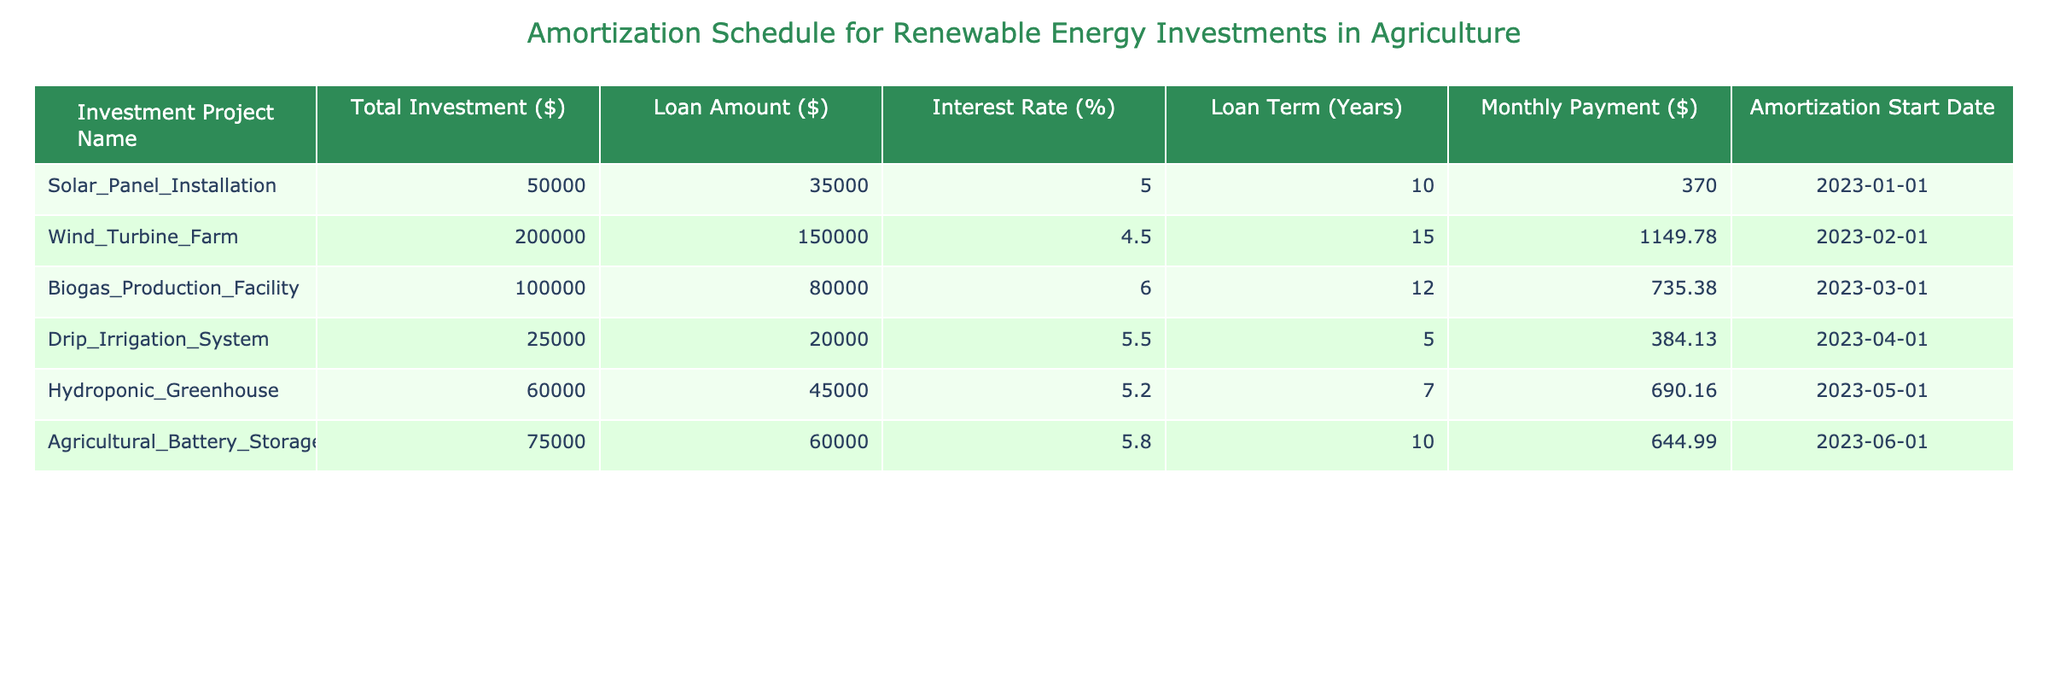What is the total investment for the Wind Turbine Farm? The total investment amount is listed in the table in the corresponding row for the Wind Turbine Farm, which indicates a value of $200,000.
Answer: 200000 What is the interest rate for the Biogas Production Facility? The interest rate for the Biogas Production Facility can be found directly in the table under its respective row, which shows a rate of 6.0%.
Answer: 6.0% Which project has the lowest loan amount? By examining the loan amounts in the table, the project with the lowest loan amount is the Drip Irrigation System, which has a loan amount of $20,000.
Answer: 20000 What is the average monthly payment across all projects? To find the average monthly payment, we first sum all the monthly payments: 370.00 + 1149.78 + 735.38 + 384.13 + 690.16 + 644.99 = 3174.44. There are 6 projects, so dividing the total by 6 gives us an average of about $529.07.
Answer: 529.07 Is the loan amount for the Agricultural Battery Storage greater than $50,000? The loan amount for the Agricultural Battery Storage is $60,000, which is indeed greater than $50,000.
Answer: Yes Which project has the longest loan term, and what is its duration? By inspecting the loan terms in the table, we find that the Wind Turbine Farm has the longest loan term of 15 years. Thus, it is identified to have the longest duration.
Answer: Wind Turbine Farm, 15 years How much total loan amount is being financed across all projects? To find the total loan amount, we add up all loan amounts: 35,000 + 150,000 + 80,000 + 20,000 + 45,000 + 60,000 = 390,000. Therefore, the total loan amount financed is $390,000.
Answer: 390000 Is there any project that has a monthly payment of over $1,000? By reviewing the monthly payments listed, we see that the Wind Turbine Farm has a monthly payment of $1,149.78, which confirms that there is, in fact, a project with a monthly payment exceeding $1,000.
Answer: Yes What is the difference between the highest and lowest interest rate from the table? The highest interest rate is for the Biogas Production Facility at 6.0%, and the lowest is for the Wind Turbine Farm at 4.5%. Therefore, the difference is 6.0% - 4.5% = 1.5%.
Answer: 1.5% 